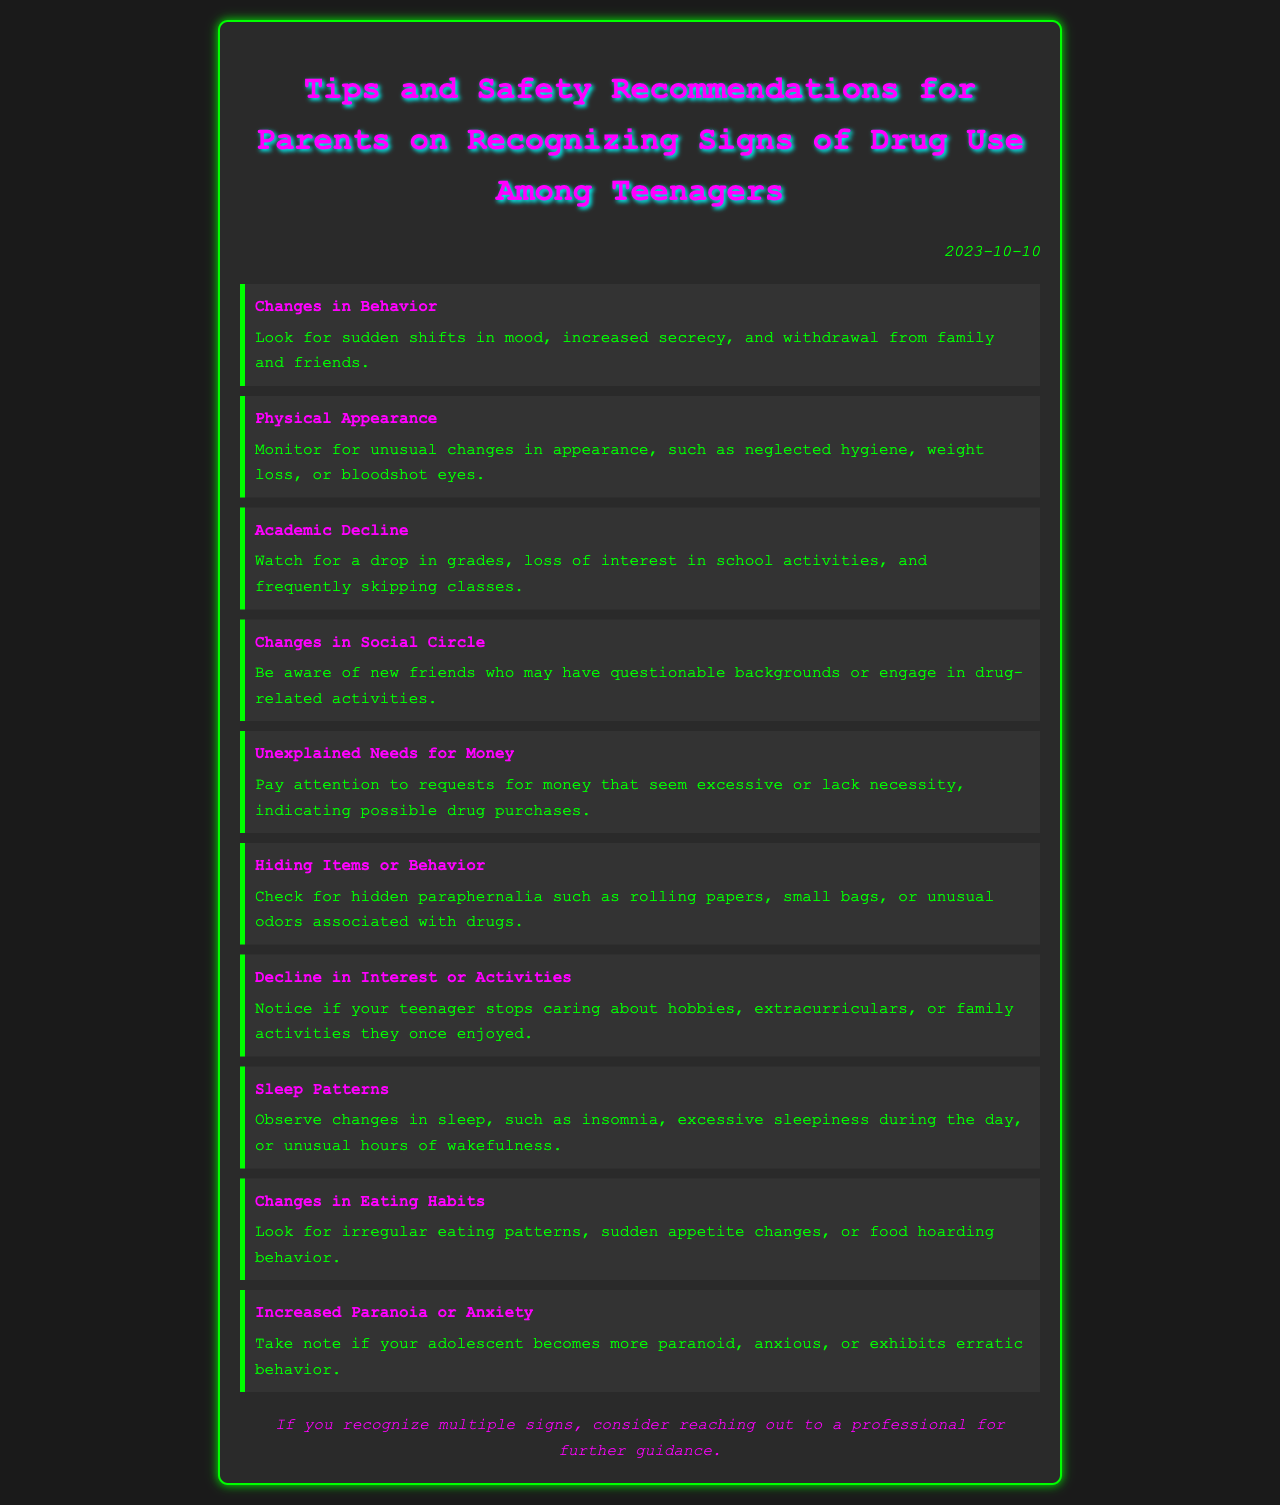What is the document title? The title is stated at the top of the document, clearly labeled.
Answer: Tips and Safety Recommendations for Parents on Recognizing Signs of Drug Use Among Teenagers What date is listed in the document? The date is mentioned at the top right of the document, indicating when it was created.
Answer: 2023-10-10 How many signs of drug use are listed? The number of signs is found by counting the items in the list provided in the document.
Answer: 10 What sign relates to academic performance? The specific sign is indicated in the relevant list item that addresses school-related behaviors.
Answer: Academic Decline What color is used for the headings? The color used for headings is specified in the document styling and can be identified in the rendered text.
Answer: Magenta Which behavior involves hiding items? The relevant item describes actions related to concealing certain objects.
Answer: Hiding Items or Behavior What should you do if you recognize multiple signs? The document provides a recommendation based on recognition of several warning signs.
Answer: Consider reaching out to a professional for further guidance What sign involves changes in social relationships? The specific item discussing changes in a teenager's friends is stated in the document.
Answer: Changes in Social Circle What indicates physical appearance issues? The document lists a sign that references visible changes related to hygiene and health.
Answer: Physical Appearance What is a possible financial concern mentioned? The document outlines a specific behavior regarding excessive requests for funds.
Answer: Unexplained Needs for Money 